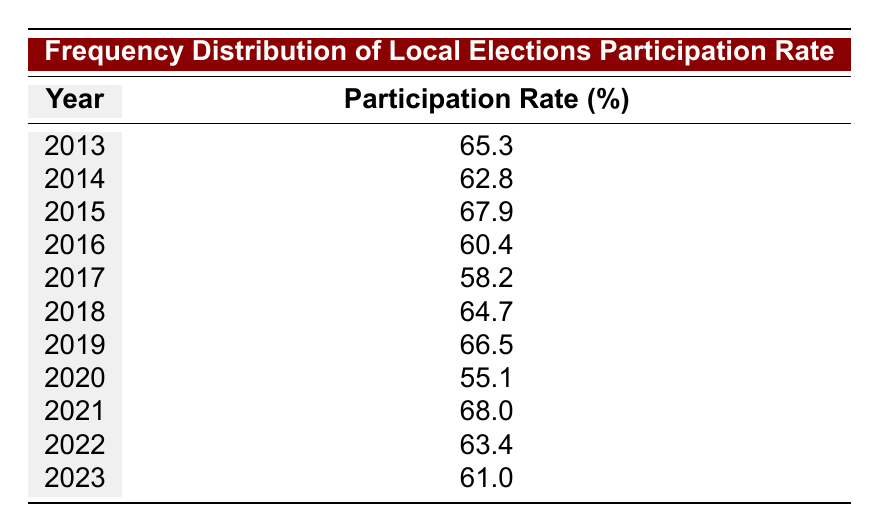What was the participation rate in 2015? Looking at the table, the year 2015 shows a participation rate of 67.9%.
Answer: 67.9 Which year had the lowest participation rate? The lowest participation rate is in 2020, which has a rate of 55.1%.
Answer: 2020 What is the average participation rate from 2013 to 2023? To find the average, we first sum the participation rates: (65.3 + 62.8 + 67.9 + 60.4 + 58.2 + 64.7 + 66.5 + 55.1 + 68.0 + 63.4 + 61.0) =  67.5. There are 11 years, so we divide this sum by 11:  67.5/11 = 61.36.
Answer: 61.36 Is the participation rate greater than 60% in 2021? In the year 2021, the participation rate is 68.0%, which is greater than 60%. Therefore, the answer is yes.
Answer: Yes Did the participation rate increase from 2017 to 2018? The participation rate in 2017 is 58.2%, and in 2018 it is 64.7%. Since 64.7 is greater than 58.2, the participation rate did indeed increase from 2017 to 2018.
Answer: Yes What year had a participation rate of 64.7%? Looking closely at the table, the rate of 64.7% is recorded in 2018.
Answer: 2018 How many years had a participation rate below 60%? The years with a participation rate below 60% are 2016 (60.4) and 2017 (58.2), and 2020 (55.1). This accounts for 3 years.
Answer: 3 Which year had the highest participation rate? By examining the table, the year with the highest participation rate is 2021, with a rate of 68.0%.
Answer: 2021 Was the participation rate in 2014 greater than in 2016? The table shows the participation rate in 2014 as 62.8% and in 2016 as 60.4%. Since 62.8% is greater than 60.4%, the answer is yes.
Answer: Yes 